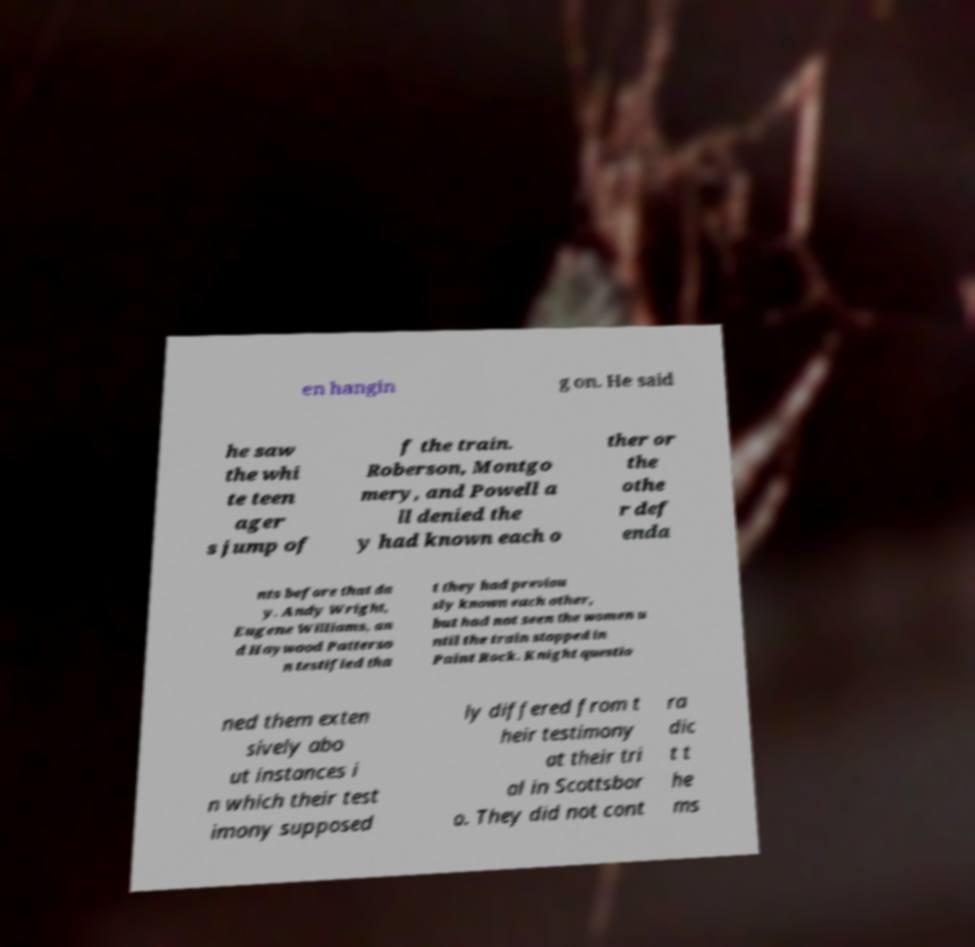There's text embedded in this image that I need extracted. Can you transcribe it verbatim? en hangin g on. He said he saw the whi te teen ager s jump of f the train. Roberson, Montgo mery, and Powell a ll denied the y had known each o ther or the othe r def enda nts before that da y. Andy Wright, Eugene Williams, an d Haywood Patterso n testified tha t they had previou sly known each other, but had not seen the women u ntil the train stopped in Paint Rock. Knight questio ned them exten sively abo ut instances i n which their test imony supposed ly differed from t heir testimony at their tri al in Scottsbor o. They did not cont ra dic t t he ms 